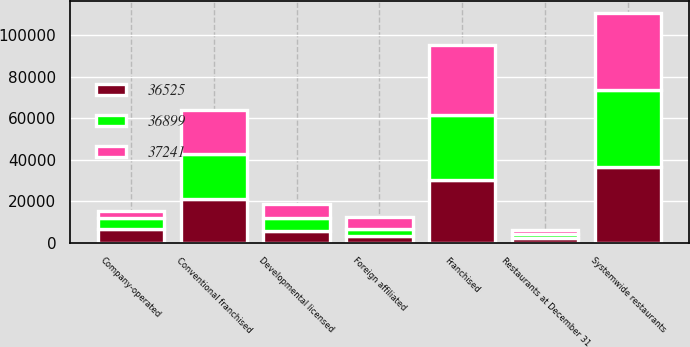Convert chart. <chart><loc_0><loc_0><loc_500><loc_500><stacked_bar_chart><ecel><fcel>Restaurants at December 31<fcel>Conventional franchised<fcel>Developmental licensed<fcel>Foreign affiliated<fcel>Franchised<fcel>Company-operated<fcel>Systemwide restaurants<nl><fcel>37241<fcel>2017<fcel>21366<fcel>6945<fcel>5797<fcel>34108<fcel>3133<fcel>37241<nl><fcel>36899<fcel>2016<fcel>21559<fcel>6300<fcel>3371<fcel>31230<fcel>5669<fcel>36899<nl><fcel>36525<fcel>2015<fcel>21147<fcel>5529<fcel>3405<fcel>30081<fcel>6444<fcel>36525<nl></chart> 